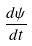<formula> <loc_0><loc_0><loc_500><loc_500>\frac { d \psi } { d t }</formula> 